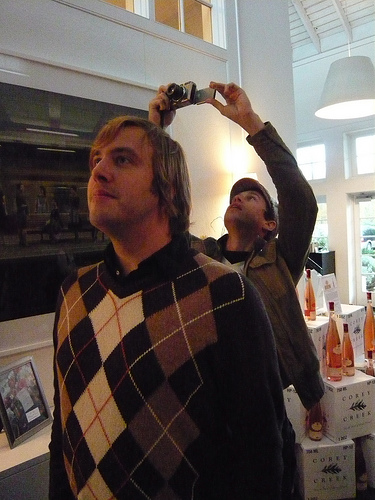<image>
Can you confirm if the phone is on the man? No. The phone is not positioned on the man. They may be near each other, but the phone is not supported by or resting on top of the man. Is there a man next to the camera? No. The man is not positioned next to the camera. They are located in different areas of the scene. 